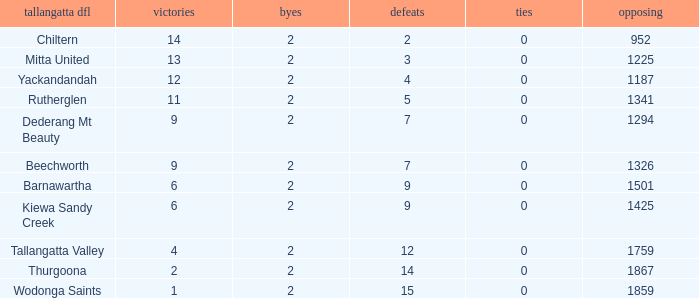What is the most byes with 11 wins and fewer than 1867 againsts? 2.0. Parse the full table. {'header': ['tallangatta dfl', 'victories', 'byes', 'defeats', 'ties', 'opposing'], 'rows': [['Chiltern', '14', '2', '2', '0', '952'], ['Mitta United', '13', '2', '3', '0', '1225'], ['Yackandandah', '12', '2', '4', '0', '1187'], ['Rutherglen', '11', '2', '5', '0', '1341'], ['Dederang Mt Beauty', '9', '2', '7', '0', '1294'], ['Beechworth', '9', '2', '7', '0', '1326'], ['Barnawartha', '6', '2', '9', '0', '1501'], ['Kiewa Sandy Creek', '6', '2', '9', '0', '1425'], ['Tallangatta Valley', '4', '2', '12', '0', '1759'], ['Thurgoona', '2', '2', '14', '0', '1867'], ['Wodonga Saints', '1', '2', '15', '0', '1859']]} 